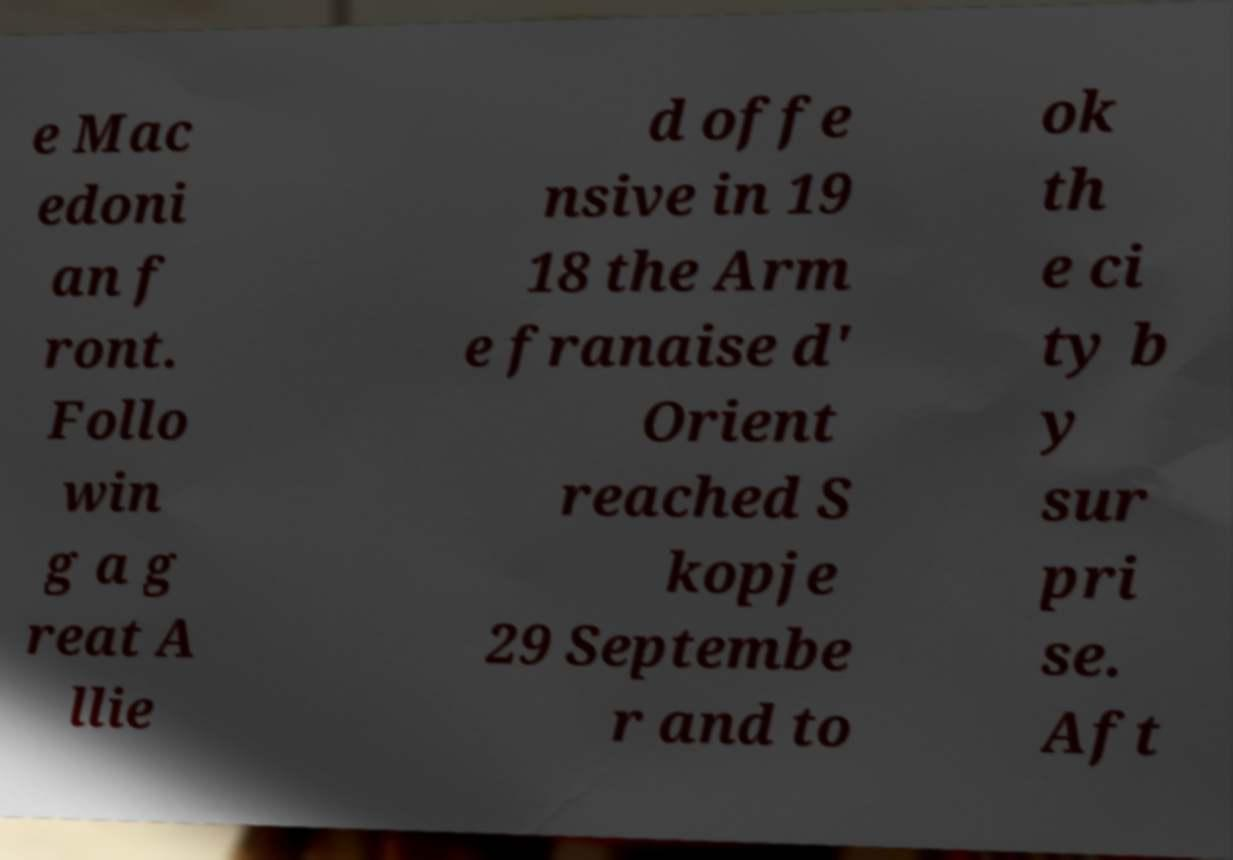For documentation purposes, I need the text within this image transcribed. Could you provide that? e Mac edoni an f ront. Follo win g a g reat A llie d offe nsive in 19 18 the Arm e franaise d' Orient reached S kopje 29 Septembe r and to ok th e ci ty b y sur pri se. Aft 